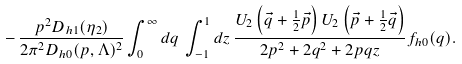<formula> <loc_0><loc_0><loc_500><loc_500>- \, \frac { p ^ { 2 } D _ { h 1 } ( \eta _ { 2 } ) } { 2 \pi ^ { 2 } D _ { h 0 } ( p , \Lambda ) ^ { 2 } } \int _ { 0 } ^ { \infty } d q \, \int _ { - 1 } ^ { 1 } d z \, \frac { U _ { 2 } \left ( \vec { q } + \frac { 1 } { 2 } \vec { p } \right ) U _ { 2 } \left ( \vec { p } + \frac { 1 } { 2 } \vec { q } \right ) } { 2 p ^ { 2 } + 2 q ^ { 2 } + 2 p q z } f _ { h 0 } ( q ) .</formula> 